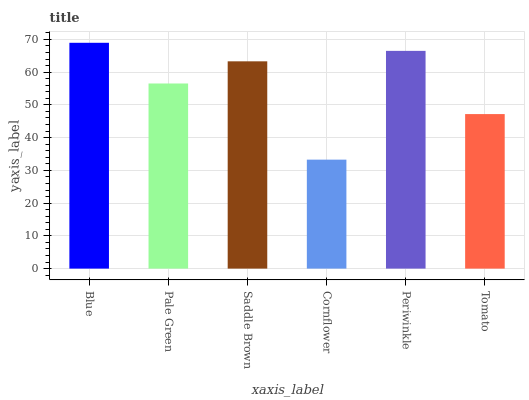Is Cornflower the minimum?
Answer yes or no. Yes. Is Blue the maximum?
Answer yes or no. Yes. Is Pale Green the minimum?
Answer yes or no. No. Is Pale Green the maximum?
Answer yes or no. No. Is Blue greater than Pale Green?
Answer yes or no. Yes. Is Pale Green less than Blue?
Answer yes or no. Yes. Is Pale Green greater than Blue?
Answer yes or no. No. Is Blue less than Pale Green?
Answer yes or no. No. Is Saddle Brown the high median?
Answer yes or no. Yes. Is Pale Green the low median?
Answer yes or no. Yes. Is Pale Green the high median?
Answer yes or no. No. Is Periwinkle the low median?
Answer yes or no. No. 